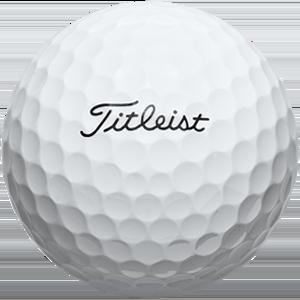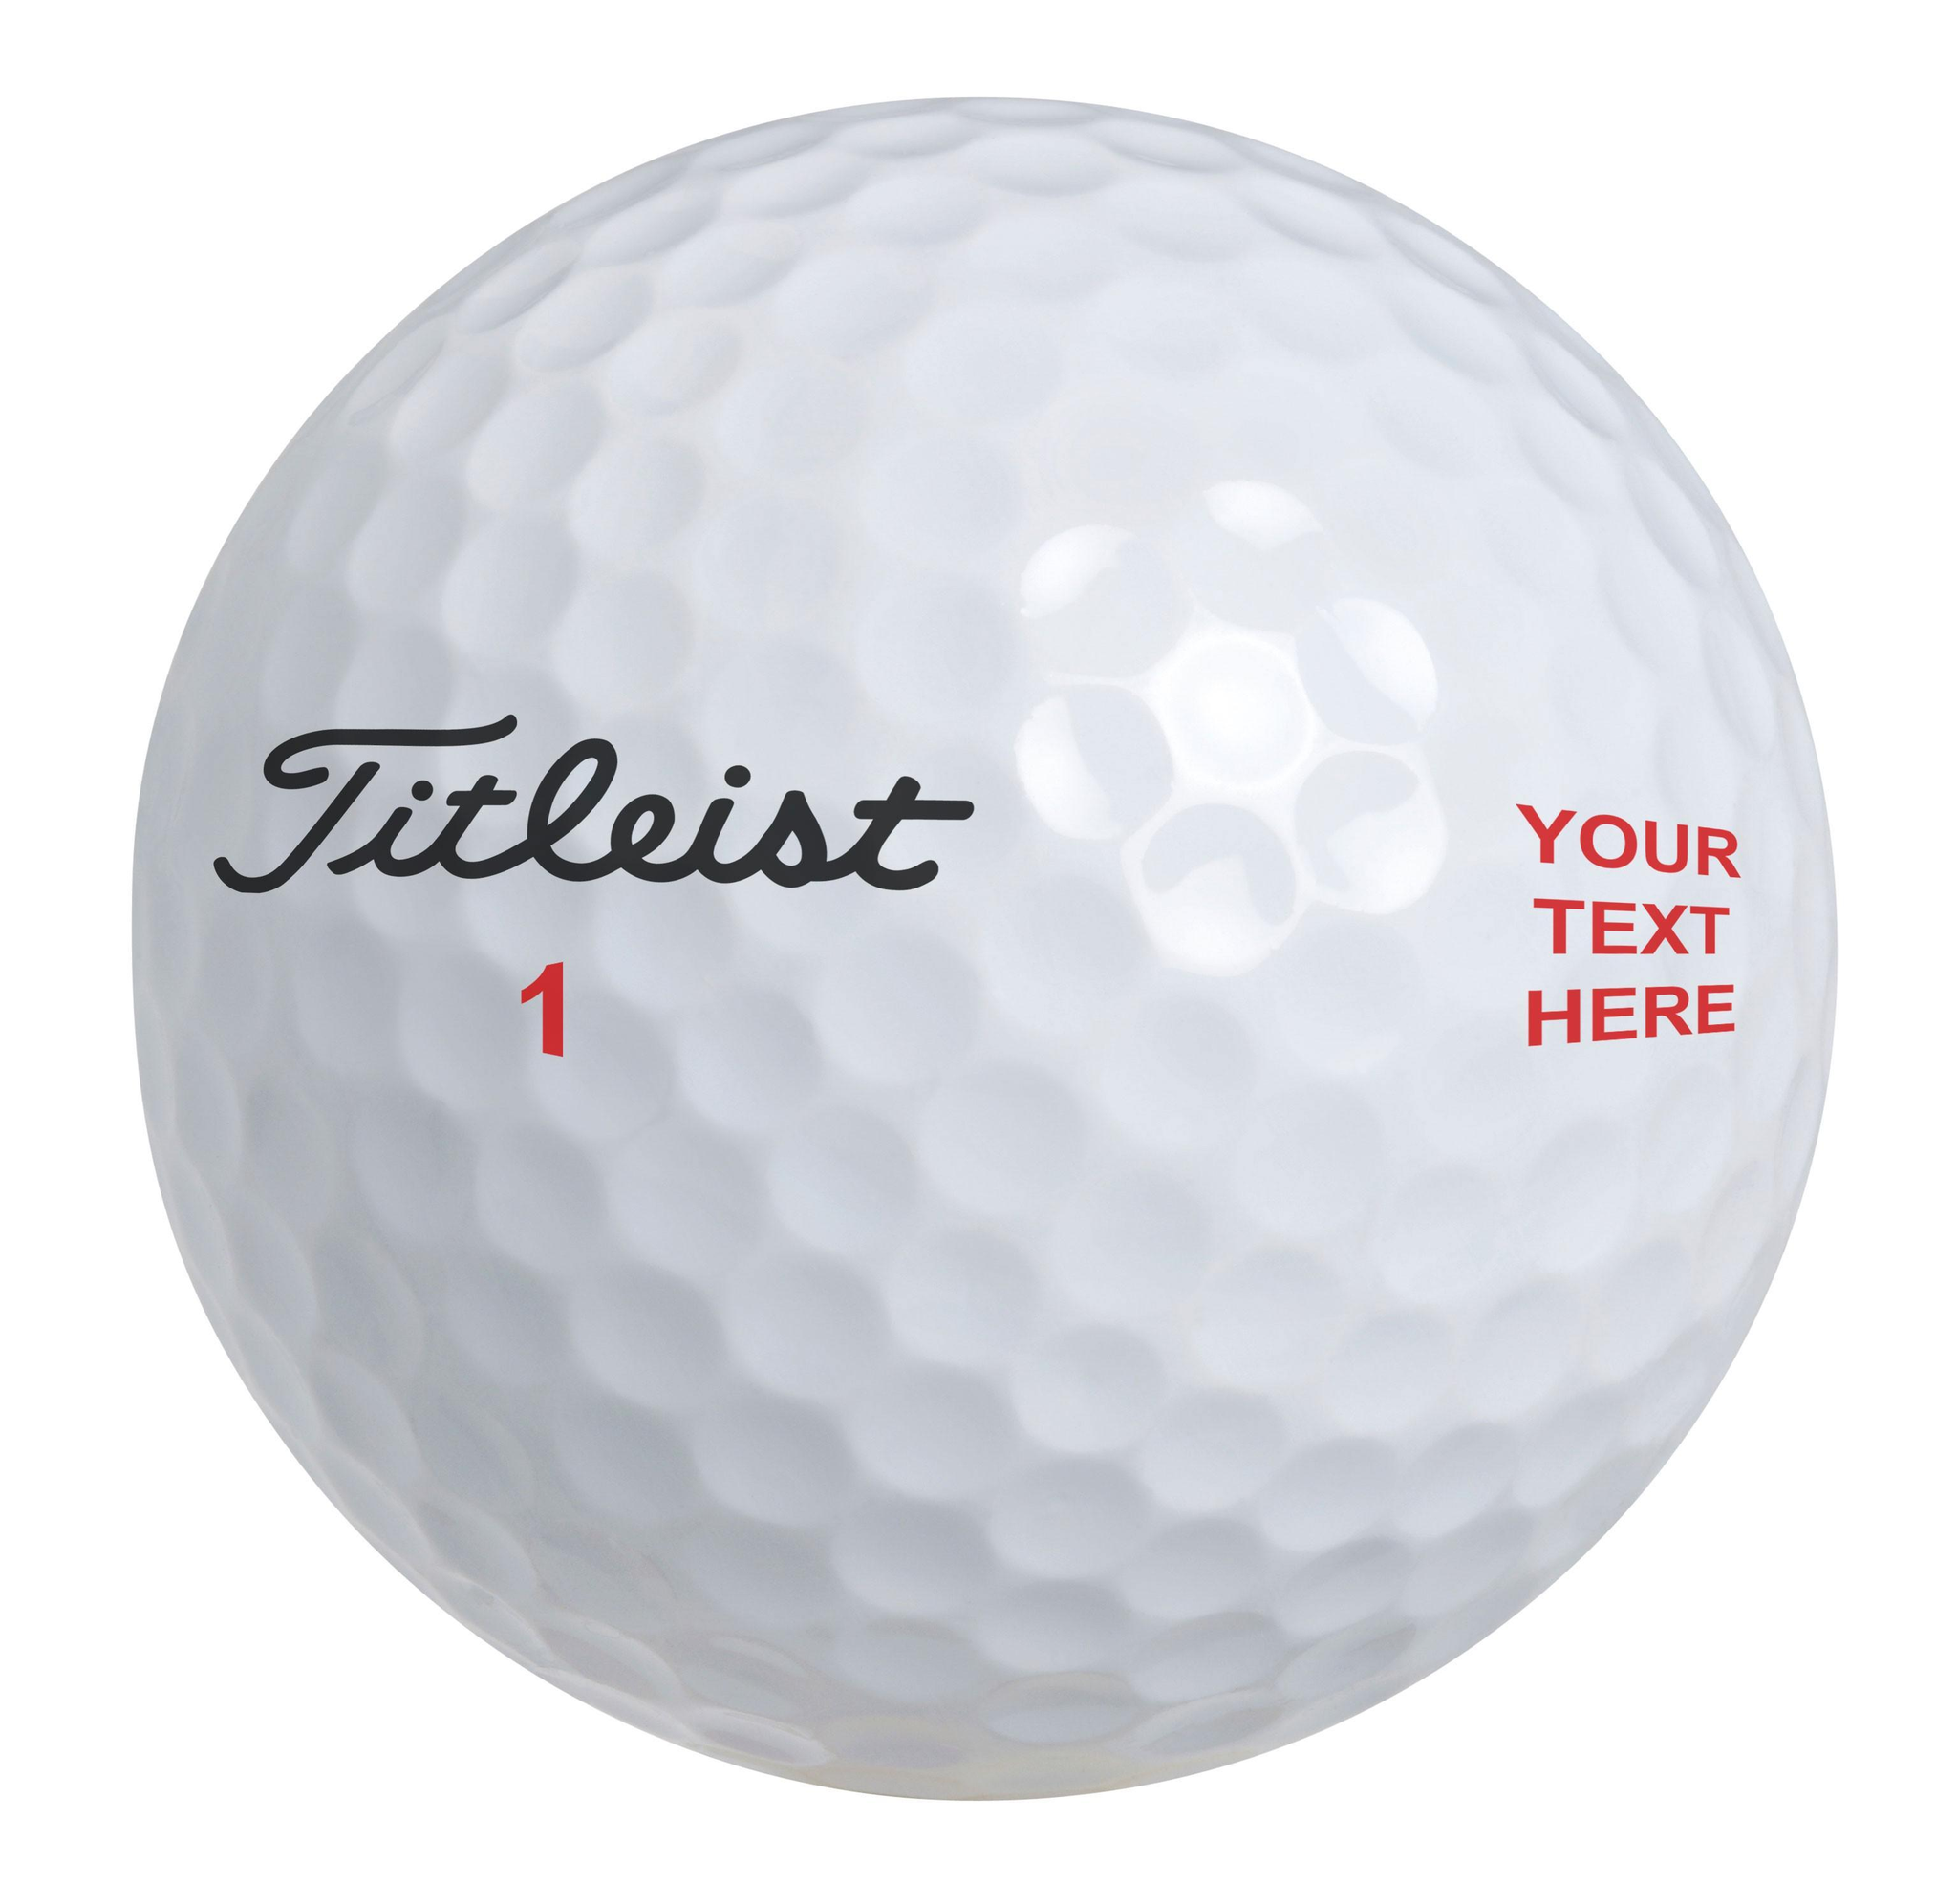The first image is the image on the left, the second image is the image on the right. Examine the images to the left and right. Is the description "There are exactly two golf balls" accurate? Answer yes or no. Yes. 